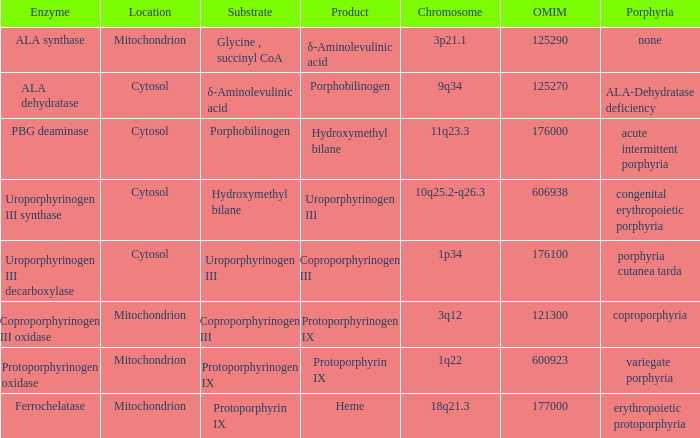What is the substrate for protoporphyrin ix? Protoporphyrinogen IX. 